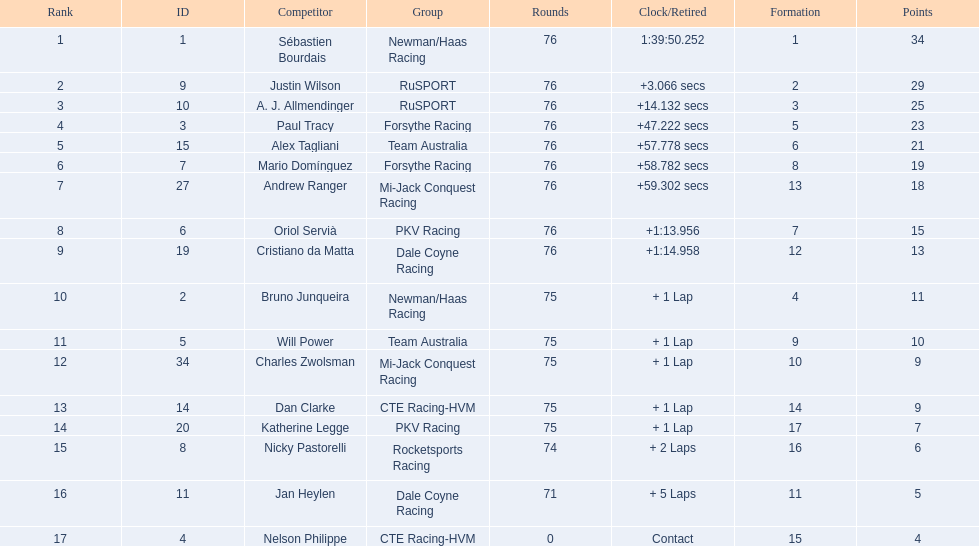Which driver earned the least amount of points. Nelson Philippe. Help me parse the entirety of this table. {'header': ['Rank', 'ID', 'Competitor', 'Group', 'Rounds', 'Clock/Retired', 'Formation', 'Points'], 'rows': [['1', '1', 'Sébastien Bourdais', 'Newman/Haas Racing', '76', '1:39:50.252', '1', '34'], ['2', '9', 'Justin Wilson', 'RuSPORT', '76', '+3.066 secs', '2', '29'], ['3', '10', 'A. J. Allmendinger', 'RuSPORT', '76', '+14.132 secs', '3', '25'], ['4', '3', 'Paul Tracy', 'Forsythe Racing', '76', '+47.222 secs', '5', '23'], ['5', '15', 'Alex Tagliani', 'Team Australia', '76', '+57.778 secs', '6', '21'], ['6', '7', 'Mario Domínguez', 'Forsythe Racing', '76', '+58.782 secs', '8', '19'], ['7', '27', 'Andrew Ranger', 'Mi-Jack Conquest Racing', '76', '+59.302 secs', '13', '18'], ['8', '6', 'Oriol Servià', 'PKV Racing', '76', '+1:13.956', '7', '15'], ['9', '19', 'Cristiano da Matta', 'Dale Coyne Racing', '76', '+1:14.958', '12', '13'], ['10', '2', 'Bruno Junqueira', 'Newman/Haas Racing', '75', '+ 1 Lap', '4', '11'], ['11', '5', 'Will Power', 'Team Australia', '75', '+ 1 Lap', '9', '10'], ['12', '34', 'Charles Zwolsman', 'Mi-Jack Conquest Racing', '75', '+ 1 Lap', '10', '9'], ['13', '14', 'Dan Clarke', 'CTE Racing-HVM', '75', '+ 1 Lap', '14', '9'], ['14', '20', 'Katherine Legge', 'PKV Racing', '75', '+ 1 Lap', '17', '7'], ['15', '8', 'Nicky Pastorelli', 'Rocketsports Racing', '74', '+ 2 Laps', '16', '6'], ['16', '11', 'Jan Heylen', 'Dale Coyne Racing', '71', '+ 5 Laps', '11', '5'], ['17', '4', 'Nelson Philippe', 'CTE Racing-HVM', '0', 'Contact', '15', '4']]} 